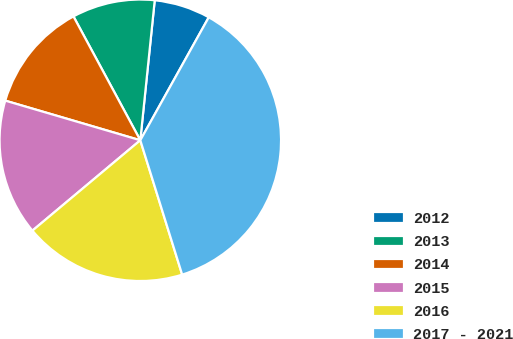Convert chart. <chart><loc_0><loc_0><loc_500><loc_500><pie_chart><fcel>2012<fcel>2013<fcel>2014<fcel>2015<fcel>2016<fcel>2017 - 2021<nl><fcel>6.45%<fcel>9.51%<fcel>12.58%<fcel>15.64%<fcel>18.71%<fcel>37.11%<nl></chart> 